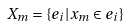Convert formula to latex. <formula><loc_0><loc_0><loc_500><loc_500>X _ { m } = \{ e _ { i } | x _ { m } \in e _ { i } \}</formula> 